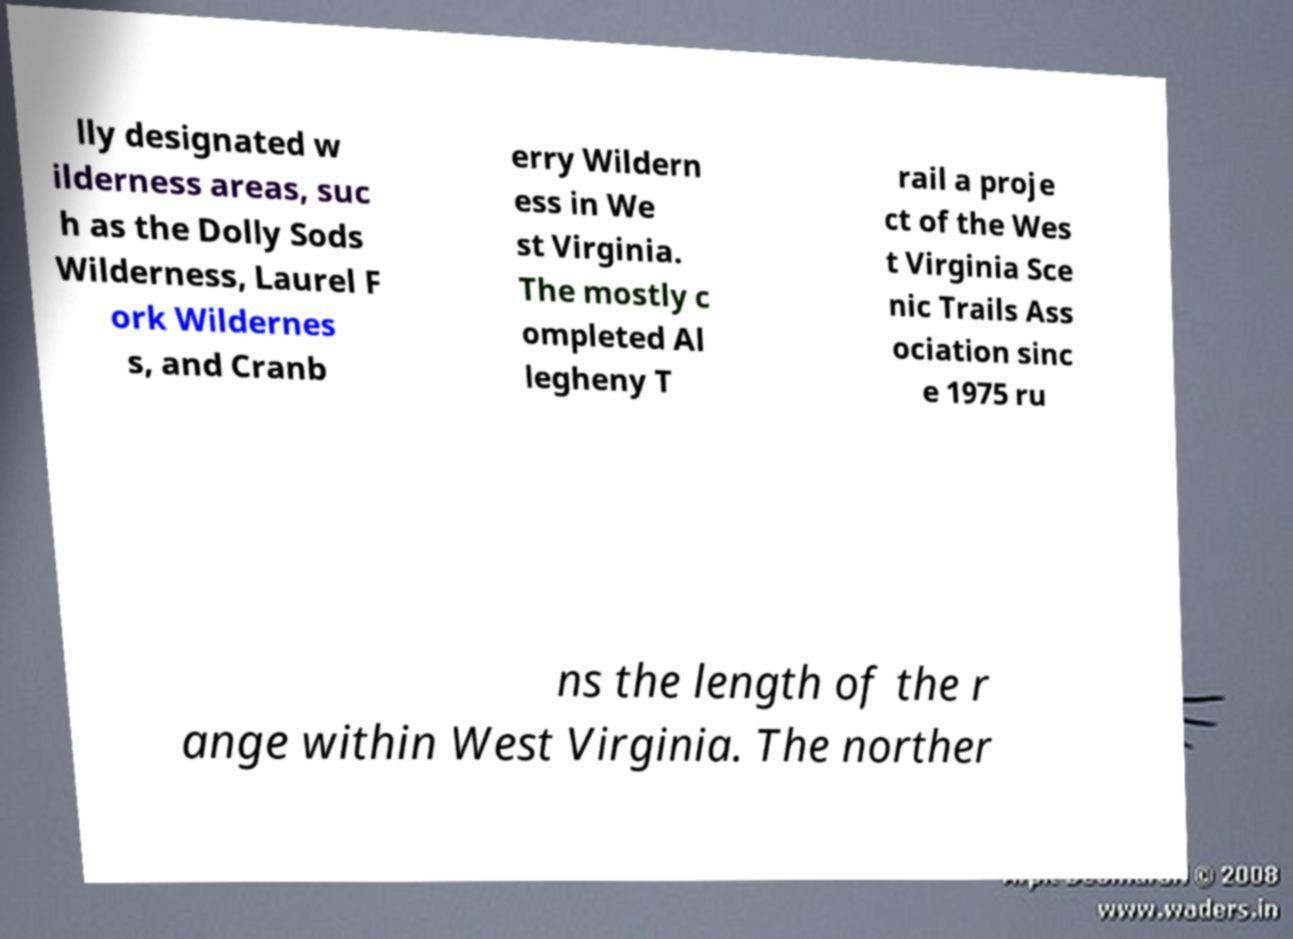Can you accurately transcribe the text from the provided image for me? lly designated w ilderness areas, suc h as the Dolly Sods Wilderness, Laurel F ork Wildernes s, and Cranb erry Wildern ess in We st Virginia. The mostly c ompleted Al legheny T rail a proje ct of the Wes t Virginia Sce nic Trails Ass ociation sinc e 1975 ru ns the length of the r ange within West Virginia. The norther 